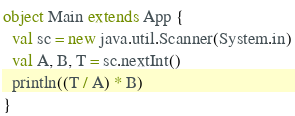Convert code to text. <code><loc_0><loc_0><loc_500><loc_500><_Scala_>object Main extends App {
  val sc = new java.util.Scanner(System.in)
  val A, B, T = sc.nextInt()
  println((T / A) * B)
}
</code> 